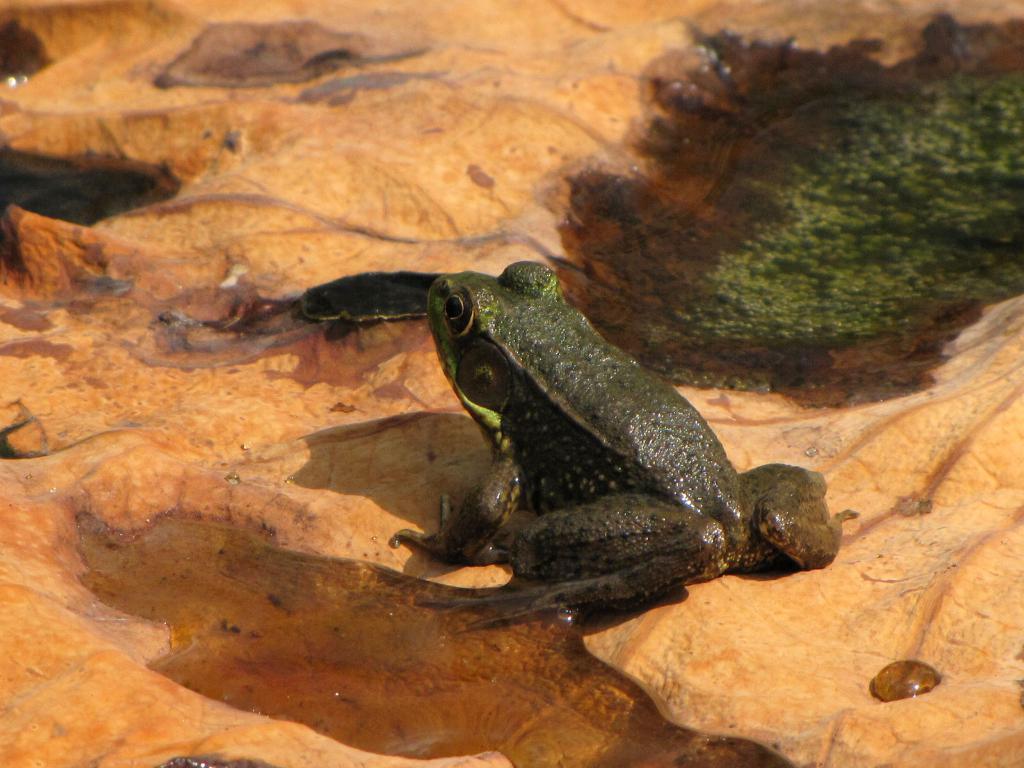Please provide a concise description of this image. In this image I can see a frog in green color on some brown color surface. 